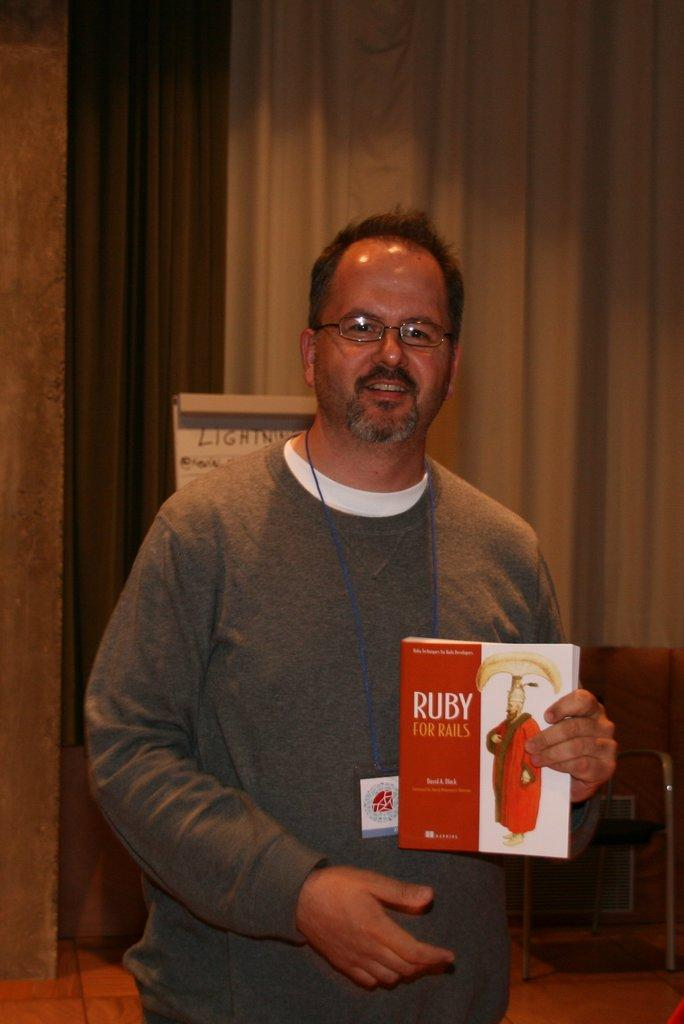<image>
Create a compact narrative representing the image presented. A man holds a Ruby for Rails book. 